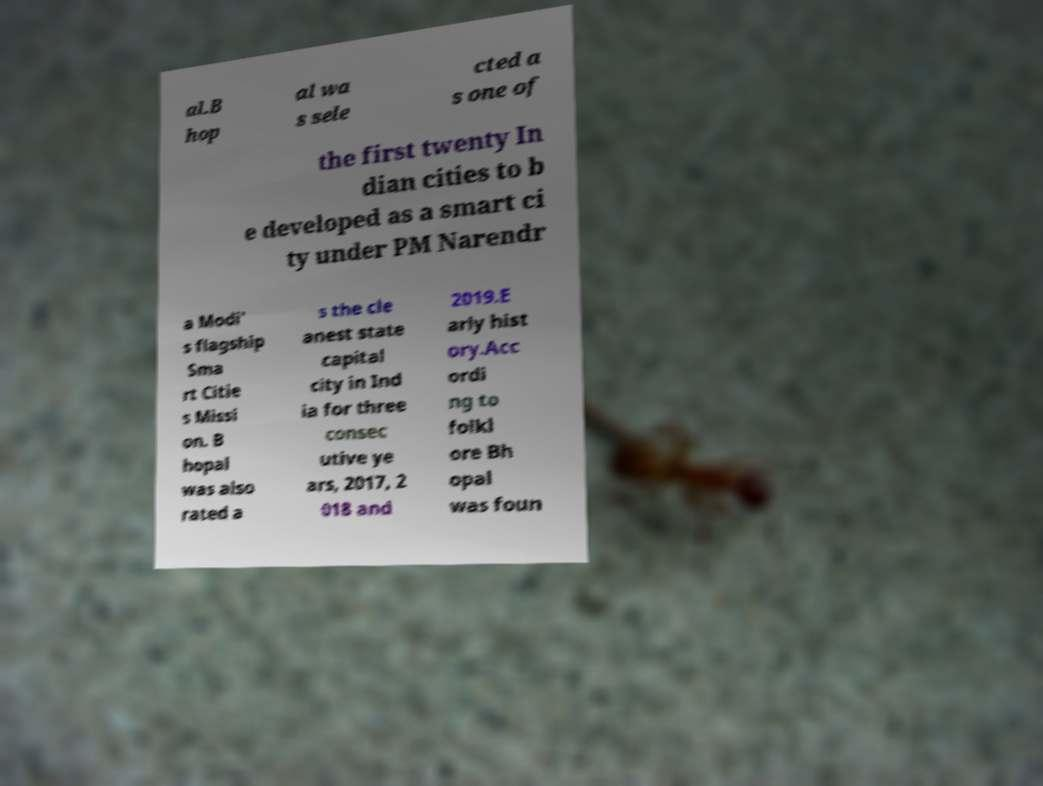Can you accurately transcribe the text from the provided image for me? al.B hop al wa s sele cted a s one of the first twenty In dian cities to b e developed as a smart ci ty under PM Narendr a Modi' s flagship Sma rt Citie s Missi on. B hopal was also rated a s the cle anest state capital city in Ind ia for three consec utive ye ars, 2017, 2 018 and 2019.E arly hist ory.Acc ordi ng to folkl ore Bh opal was foun 